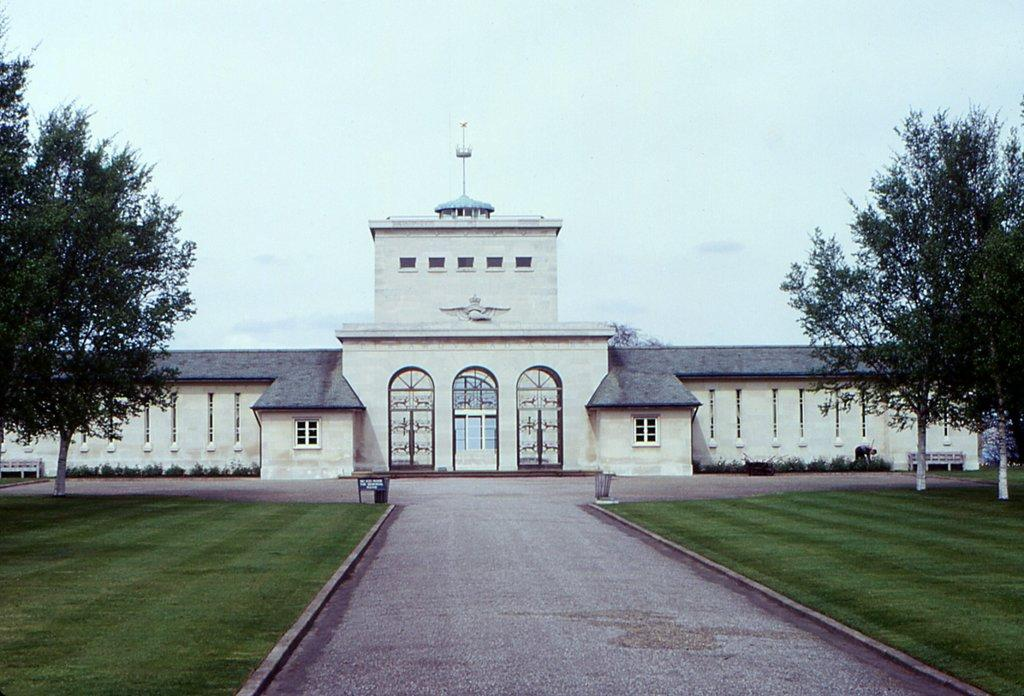What type of structure is visible in the image? There is a building in the image. What is located in front of the building? There is a pavement in front of the building. What type of vegetation is beside the pavement? There is grass beside the pavement. What can be seen growing on the grass? There are trees on the grass. What type of leaf can be seen blowing in the wind in the image? There is no leaf visible in the image, nor is there any wind blowing. 